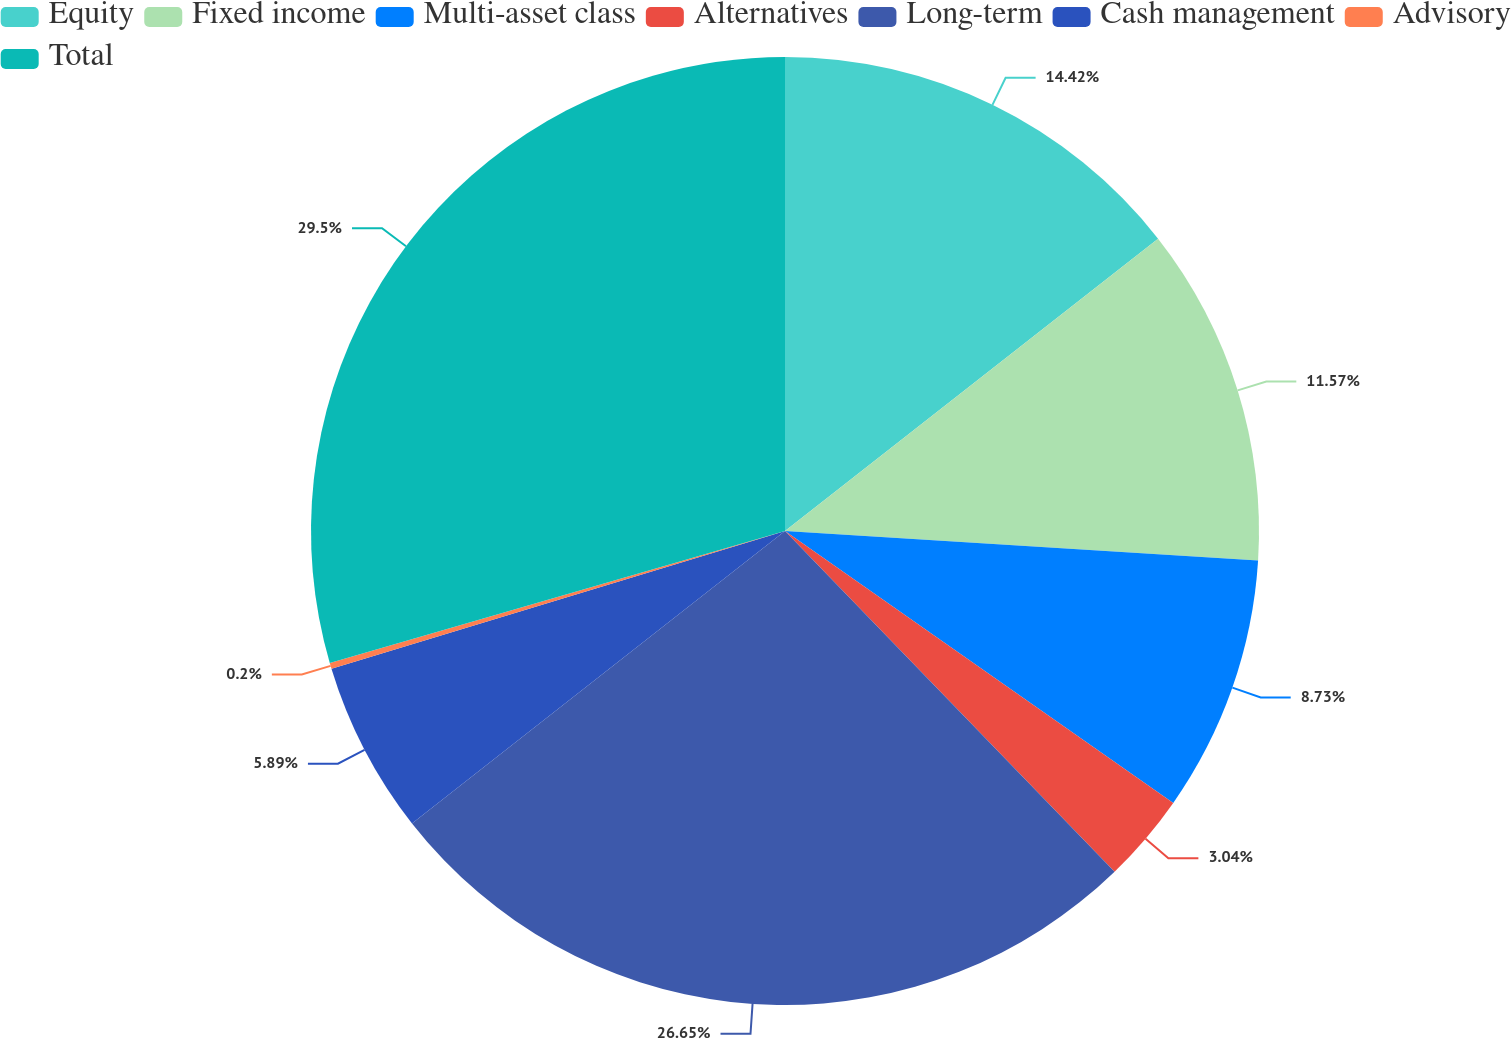Convert chart to OTSL. <chart><loc_0><loc_0><loc_500><loc_500><pie_chart><fcel>Equity<fcel>Fixed income<fcel>Multi-asset class<fcel>Alternatives<fcel>Long-term<fcel>Cash management<fcel>Advisory<fcel>Total<nl><fcel>14.42%<fcel>11.57%<fcel>8.73%<fcel>3.04%<fcel>26.65%<fcel>5.89%<fcel>0.2%<fcel>29.49%<nl></chart> 